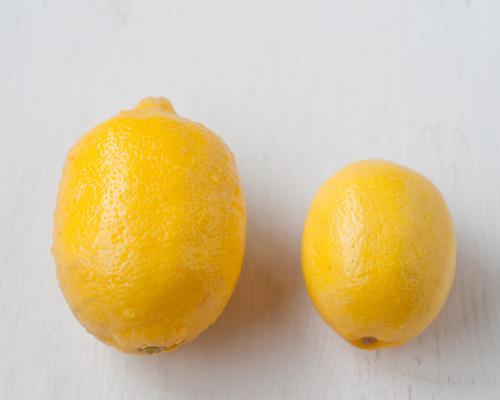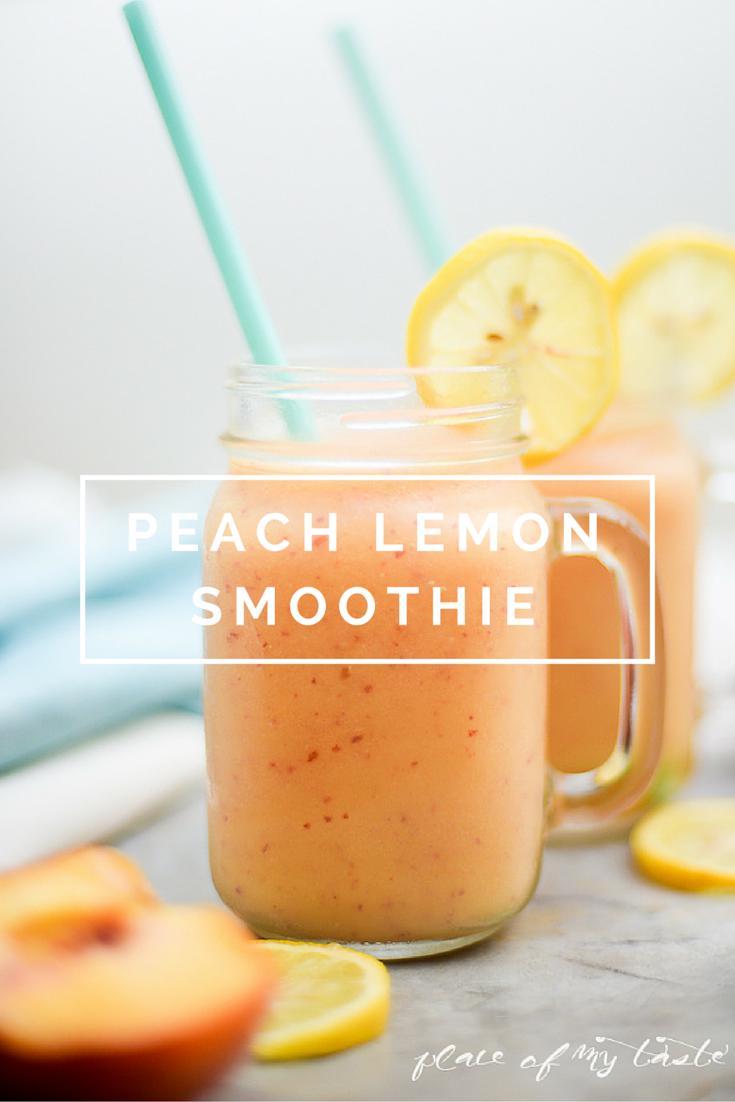The first image is the image on the left, the second image is the image on the right. Evaluate the accuracy of this statement regarding the images: "The right image contains two sliced lemons hanging from the lid of two glass smoothie cups.". Is it true? Answer yes or no. Yes. 